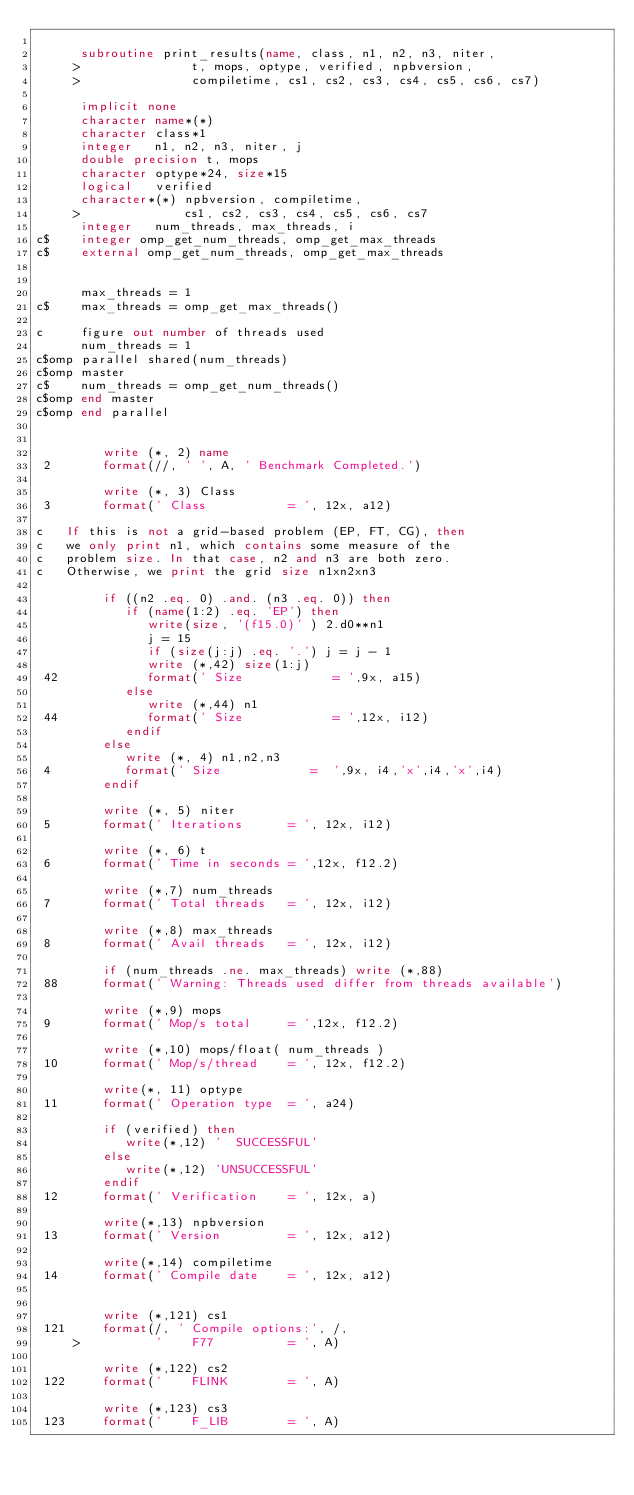Convert code to text. <code><loc_0><loc_0><loc_500><loc_500><_FORTRAN_>
      subroutine print_results(name, class, n1, n2, n3, niter, 
     >               t, mops, optype, verified, npbversion, 
     >               compiletime, cs1, cs2, cs3, cs4, cs5, cs6, cs7)
      
      implicit none
      character name*(*)
      character class*1
      integer   n1, n2, n3, niter, j
      double precision t, mops
      character optype*24, size*15
      logical   verified
      character*(*) npbversion, compiletime, 
     >              cs1, cs2, cs3, cs4, cs5, cs6, cs7
      integer   num_threads, max_threads, i
c$    integer omp_get_num_threads, omp_get_max_threads
c$    external omp_get_num_threads, omp_get_max_threads


      max_threads = 1
c$    max_threads = omp_get_max_threads()

c     figure out number of threads used
      num_threads = 1
c$omp parallel shared(num_threads)
c$omp master
c$    num_threads = omp_get_num_threads()
c$omp end master
c$omp end parallel


         write (*, 2) name
 2       format(//, ' ', A, ' Benchmark Completed.')

         write (*, 3) Class
 3       format(' Class           = ', 12x, a12)

c   If this is not a grid-based problem (EP, FT, CG), then
c   we only print n1, which contains some measure of the
c   problem size. In that case, n2 and n3 are both zero.
c   Otherwise, we print the grid size n1xn2xn3

         if ((n2 .eq. 0) .and. (n3 .eq. 0)) then
            if (name(1:2) .eq. 'EP') then
               write(size, '(f15.0)' ) 2.d0**n1
               j = 15
               if (size(j:j) .eq. '.') j = j - 1
               write (*,42) size(1:j)
 42            format(' Size            = ',9x, a15)
            else
               write (*,44) n1
 44            format(' Size            = ',12x, i12)
            endif
         else
            write (*, 4) n1,n2,n3
 4          format(' Size            =  ',9x, i4,'x',i4,'x',i4)
         endif

         write (*, 5) niter
 5       format(' Iterations      = ', 12x, i12)
         
         write (*, 6) t
 6       format(' Time in seconds = ',12x, f12.2)

         write (*,7) num_threads
 7       format(' Total threads   = ', 12x, i12)
         
         write (*,8) max_threads
 8       format(' Avail threads   = ', 12x, i12)

         if (num_threads .ne. max_threads) write (*,88) 
 88      format(' Warning: Threads used differ from threads available')

         write (*,9) mops
 9       format(' Mop/s total     = ',12x, f12.2)

         write (*,10) mops/float( num_threads )
 10      format(' Mop/s/thread    = ', 12x, f12.2)        

         write(*, 11) optype
 11      format(' Operation type  = ', a24)

         if (verified) then 
            write(*,12) '  SUCCESSFUL'
         else
            write(*,12) 'UNSUCCESSFUL'
         endif
 12      format(' Verification    = ', 12x, a)

         write(*,13) npbversion
 13      format(' Version         = ', 12x, a12)

         write(*,14) compiletime
 14      format(' Compile date    = ', 12x, a12)


         write (*,121) cs1
 121     format(/, ' Compile options:', /, 
     >          '    F77          = ', A)

         write (*,122) cs2
 122     format('    FLINK        = ', A)

         write (*,123) cs3
 123     format('    F_LIB        = ', A)
</code> 